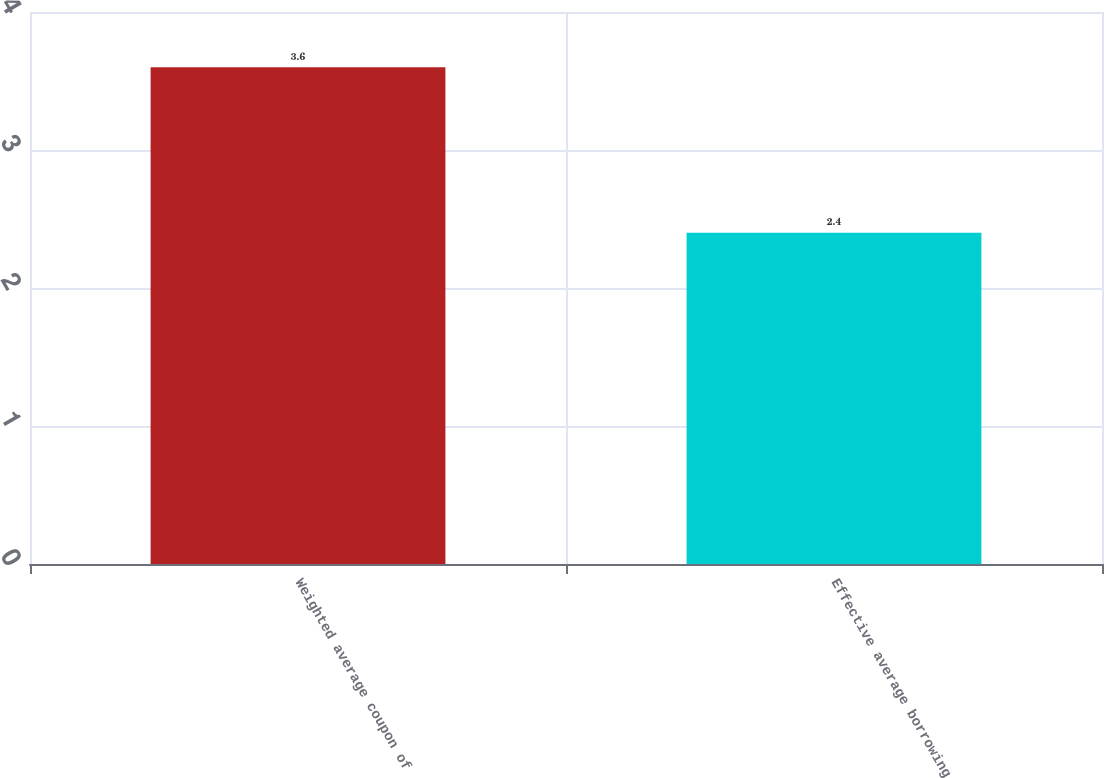<chart> <loc_0><loc_0><loc_500><loc_500><bar_chart><fcel>Weighted average coupon of<fcel>Effective average borrowing<nl><fcel>3.6<fcel>2.4<nl></chart> 